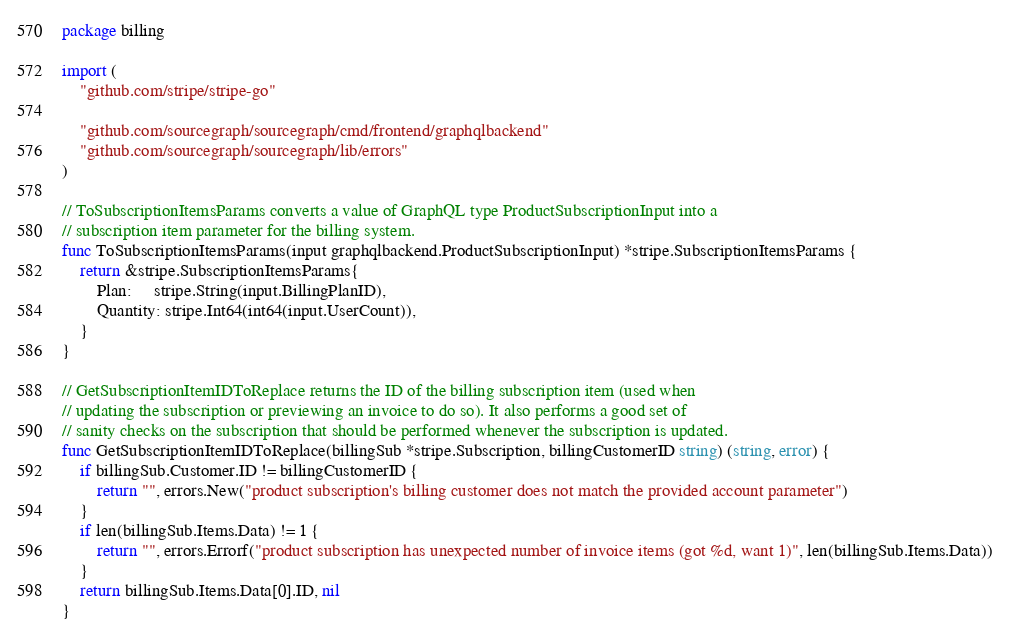Convert code to text. <code><loc_0><loc_0><loc_500><loc_500><_Go_>package billing

import (
	"github.com/stripe/stripe-go"

	"github.com/sourcegraph/sourcegraph/cmd/frontend/graphqlbackend"
	"github.com/sourcegraph/sourcegraph/lib/errors"
)

// ToSubscriptionItemsParams converts a value of GraphQL type ProductSubscriptionInput into a
// subscription item parameter for the billing system.
func ToSubscriptionItemsParams(input graphqlbackend.ProductSubscriptionInput) *stripe.SubscriptionItemsParams {
	return &stripe.SubscriptionItemsParams{
		Plan:     stripe.String(input.BillingPlanID),
		Quantity: stripe.Int64(int64(input.UserCount)),
	}
}

// GetSubscriptionItemIDToReplace returns the ID of the billing subscription item (used when
// updating the subscription or previewing an invoice to do so). It also performs a good set of
// sanity checks on the subscription that should be performed whenever the subscription is updated.
func GetSubscriptionItemIDToReplace(billingSub *stripe.Subscription, billingCustomerID string) (string, error) {
	if billingSub.Customer.ID != billingCustomerID {
		return "", errors.New("product subscription's billing customer does not match the provided account parameter")
	}
	if len(billingSub.Items.Data) != 1 {
		return "", errors.Errorf("product subscription has unexpected number of invoice items (got %d, want 1)", len(billingSub.Items.Data))
	}
	return billingSub.Items.Data[0].ID, nil
}
</code> 